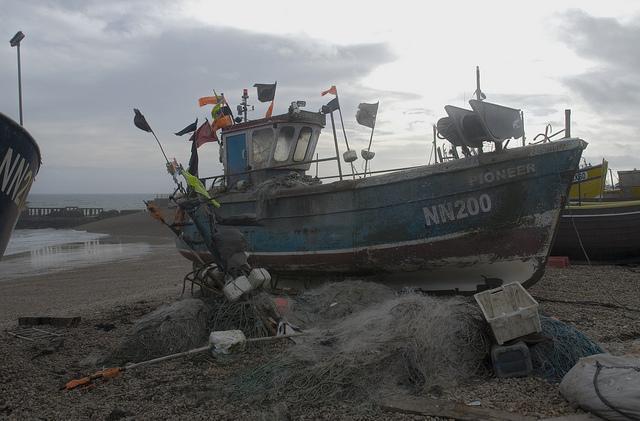How many numbers appear on the side of the ship?
Give a very brief answer. 3. How many boats are in the picture?
Give a very brief answer. 3. How many red cars are there?
Give a very brief answer. 0. 